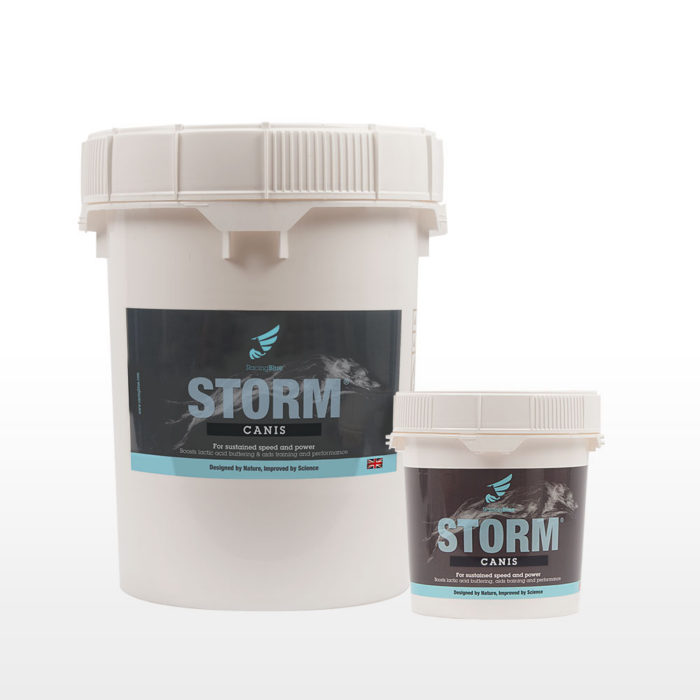What ingredients might be included in STORM CANIS that aid in enhancing canine performance? STORM CANIS likely includes a combination of amino acids, vitamins, and minerals which are essential for muscle recovery, energy production, and overall vitality of dogs. Ingredients such as glucosamine might also be included to support joint health, especially beneficial for active and aging dogs. 